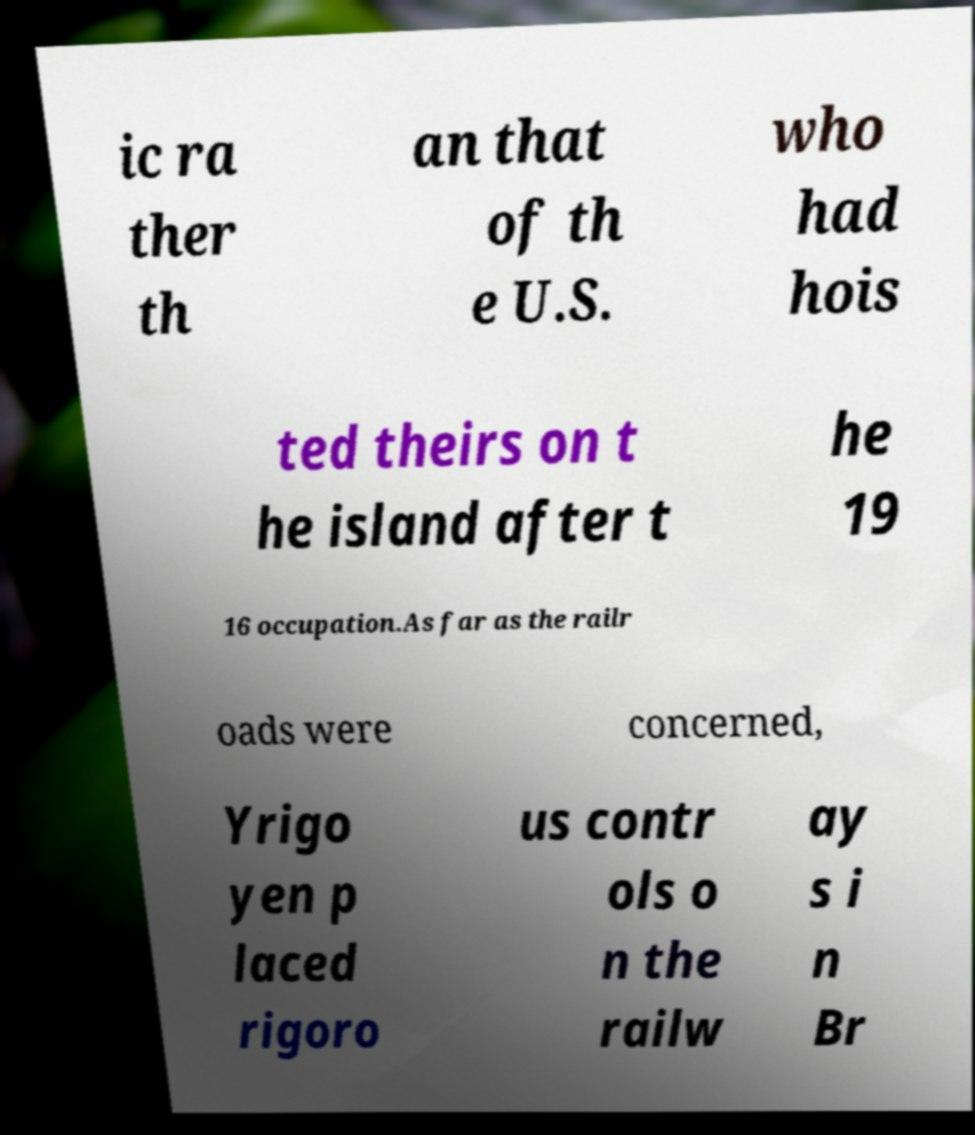For documentation purposes, I need the text within this image transcribed. Could you provide that? ic ra ther th an that of th e U.S. who had hois ted theirs on t he island after t he 19 16 occupation.As far as the railr oads were concerned, Yrigo yen p laced rigoro us contr ols o n the railw ay s i n Br 